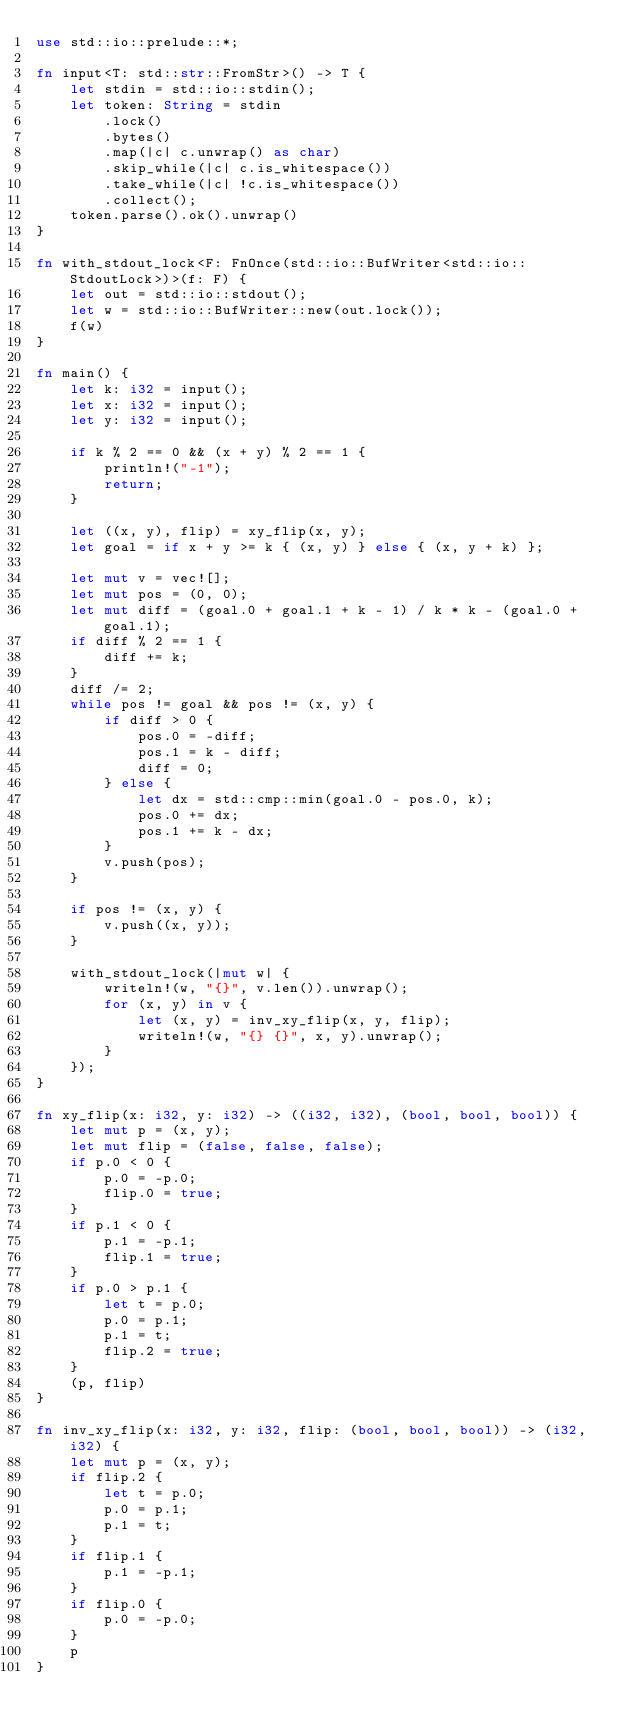<code> <loc_0><loc_0><loc_500><loc_500><_Rust_>use std::io::prelude::*;

fn input<T: std::str::FromStr>() -> T {
    let stdin = std::io::stdin();
    let token: String = stdin
        .lock()
        .bytes()
        .map(|c| c.unwrap() as char)
        .skip_while(|c| c.is_whitespace())
        .take_while(|c| !c.is_whitespace())
        .collect();
    token.parse().ok().unwrap()
}

fn with_stdout_lock<F: FnOnce(std::io::BufWriter<std::io::StdoutLock>)>(f: F) {
    let out = std::io::stdout();
    let w = std::io::BufWriter::new(out.lock());
    f(w)
}

fn main() {
    let k: i32 = input();
    let x: i32 = input();
    let y: i32 = input();

    if k % 2 == 0 && (x + y) % 2 == 1 {
        println!("-1");
        return;
    }

    let ((x, y), flip) = xy_flip(x, y);
    let goal = if x + y >= k { (x, y) } else { (x, y + k) };

    let mut v = vec![];
    let mut pos = (0, 0);
    let mut diff = (goal.0 + goal.1 + k - 1) / k * k - (goal.0 + goal.1);
    if diff % 2 == 1 {
        diff += k;
    }
    diff /= 2;
    while pos != goal && pos != (x, y) {
        if diff > 0 {
            pos.0 = -diff;
            pos.1 = k - diff;
            diff = 0;
        } else {
            let dx = std::cmp::min(goal.0 - pos.0, k);
            pos.0 += dx;
            pos.1 += k - dx;
        }
        v.push(pos);
    }

    if pos != (x, y) {
        v.push((x, y));
    }

    with_stdout_lock(|mut w| {
        writeln!(w, "{}", v.len()).unwrap();
        for (x, y) in v {
            let (x, y) = inv_xy_flip(x, y, flip);
            writeln!(w, "{} {}", x, y).unwrap();
        }
    });
}

fn xy_flip(x: i32, y: i32) -> ((i32, i32), (bool, bool, bool)) {
    let mut p = (x, y);
    let mut flip = (false, false, false);
    if p.0 < 0 {
        p.0 = -p.0;
        flip.0 = true;
    }
    if p.1 < 0 {
        p.1 = -p.1;
        flip.1 = true;
    }
    if p.0 > p.1 {
        let t = p.0;
        p.0 = p.1;
        p.1 = t;
        flip.2 = true;
    }
    (p, flip)
}

fn inv_xy_flip(x: i32, y: i32, flip: (bool, bool, bool)) -> (i32, i32) {
    let mut p = (x, y);
    if flip.2 {
        let t = p.0;
        p.0 = p.1;
        p.1 = t;
    }
    if flip.1 {
        p.1 = -p.1;
    }
    if flip.0 {
        p.0 = -p.0;
    }
    p
}
</code> 